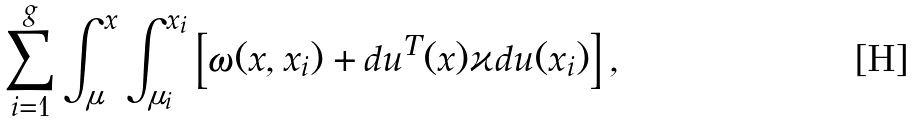<formula> <loc_0><loc_0><loc_500><loc_500>\sum _ { i = 1 } ^ { g } \int _ { \mu } ^ { x } \int _ { \mu _ { i } } ^ { x _ { i } } \left [ \omega ( x , x _ { i } ) + d u ^ { T } ( x ) \varkappa d u ( x _ { i } ) \right ] ,</formula> 